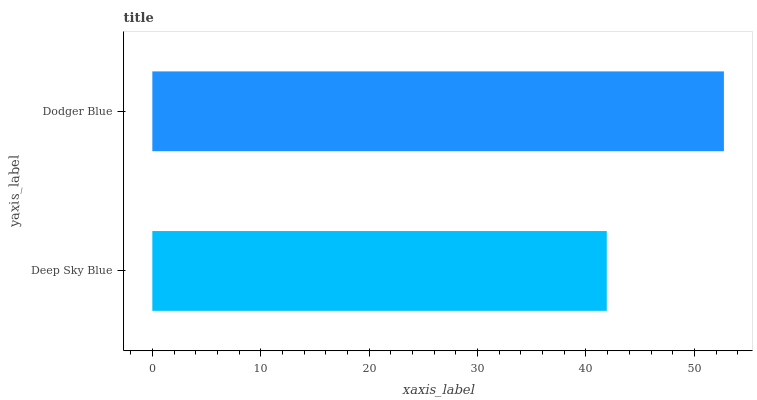Is Deep Sky Blue the minimum?
Answer yes or no. Yes. Is Dodger Blue the maximum?
Answer yes or no. Yes. Is Dodger Blue the minimum?
Answer yes or no. No. Is Dodger Blue greater than Deep Sky Blue?
Answer yes or no. Yes. Is Deep Sky Blue less than Dodger Blue?
Answer yes or no. Yes. Is Deep Sky Blue greater than Dodger Blue?
Answer yes or no. No. Is Dodger Blue less than Deep Sky Blue?
Answer yes or no. No. Is Dodger Blue the high median?
Answer yes or no. Yes. Is Deep Sky Blue the low median?
Answer yes or no. Yes. Is Deep Sky Blue the high median?
Answer yes or no. No. Is Dodger Blue the low median?
Answer yes or no. No. 